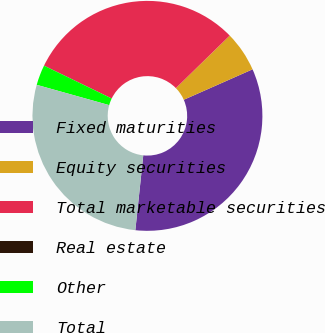Convert chart. <chart><loc_0><loc_0><loc_500><loc_500><pie_chart><fcel>Fixed maturities<fcel>Equity securities<fcel>Total marketable securities<fcel>Real estate<fcel>Other<fcel>Total<nl><fcel>33.31%<fcel>5.67%<fcel>30.49%<fcel>0.02%<fcel>2.84%<fcel>27.67%<nl></chart> 